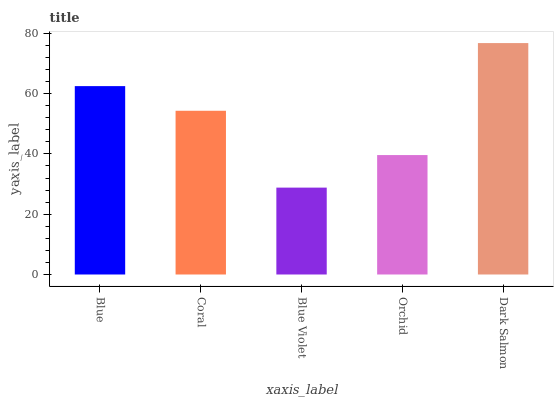Is Coral the minimum?
Answer yes or no. No. Is Coral the maximum?
Answer yes or no. No. Is Blue greater than Coral?
Answer yes or no. Yes. Is Coral less than Blue?
Answer yes or no. Yes. Is Coral greater than Blue?
Answer yes or no. No. Is Blue less than Coral?
Answer yes or no. No. Is Coral the high median?
Answer yes or no. Yes. Is Coral the low median?
Answer yes or no. Yes. Is Orchid the high median?
Answer yes or no. No. Is Orchid the low median?
Answer yes or no. No. 